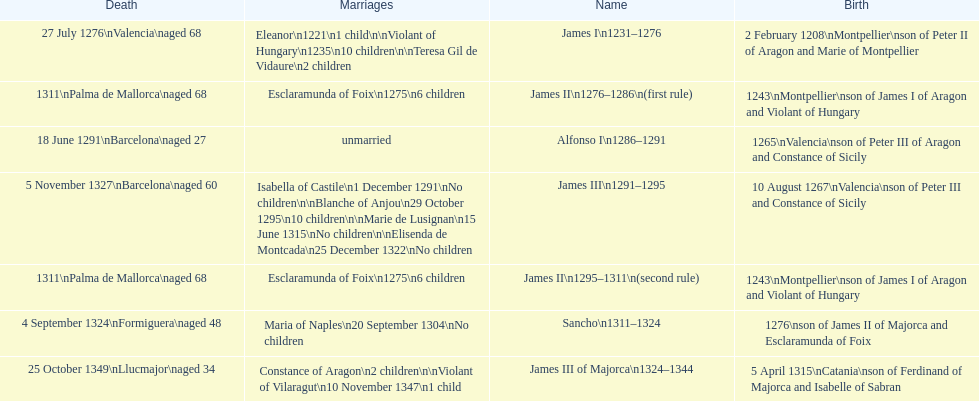How long was james ii in power, including his second rule? 26 years. 